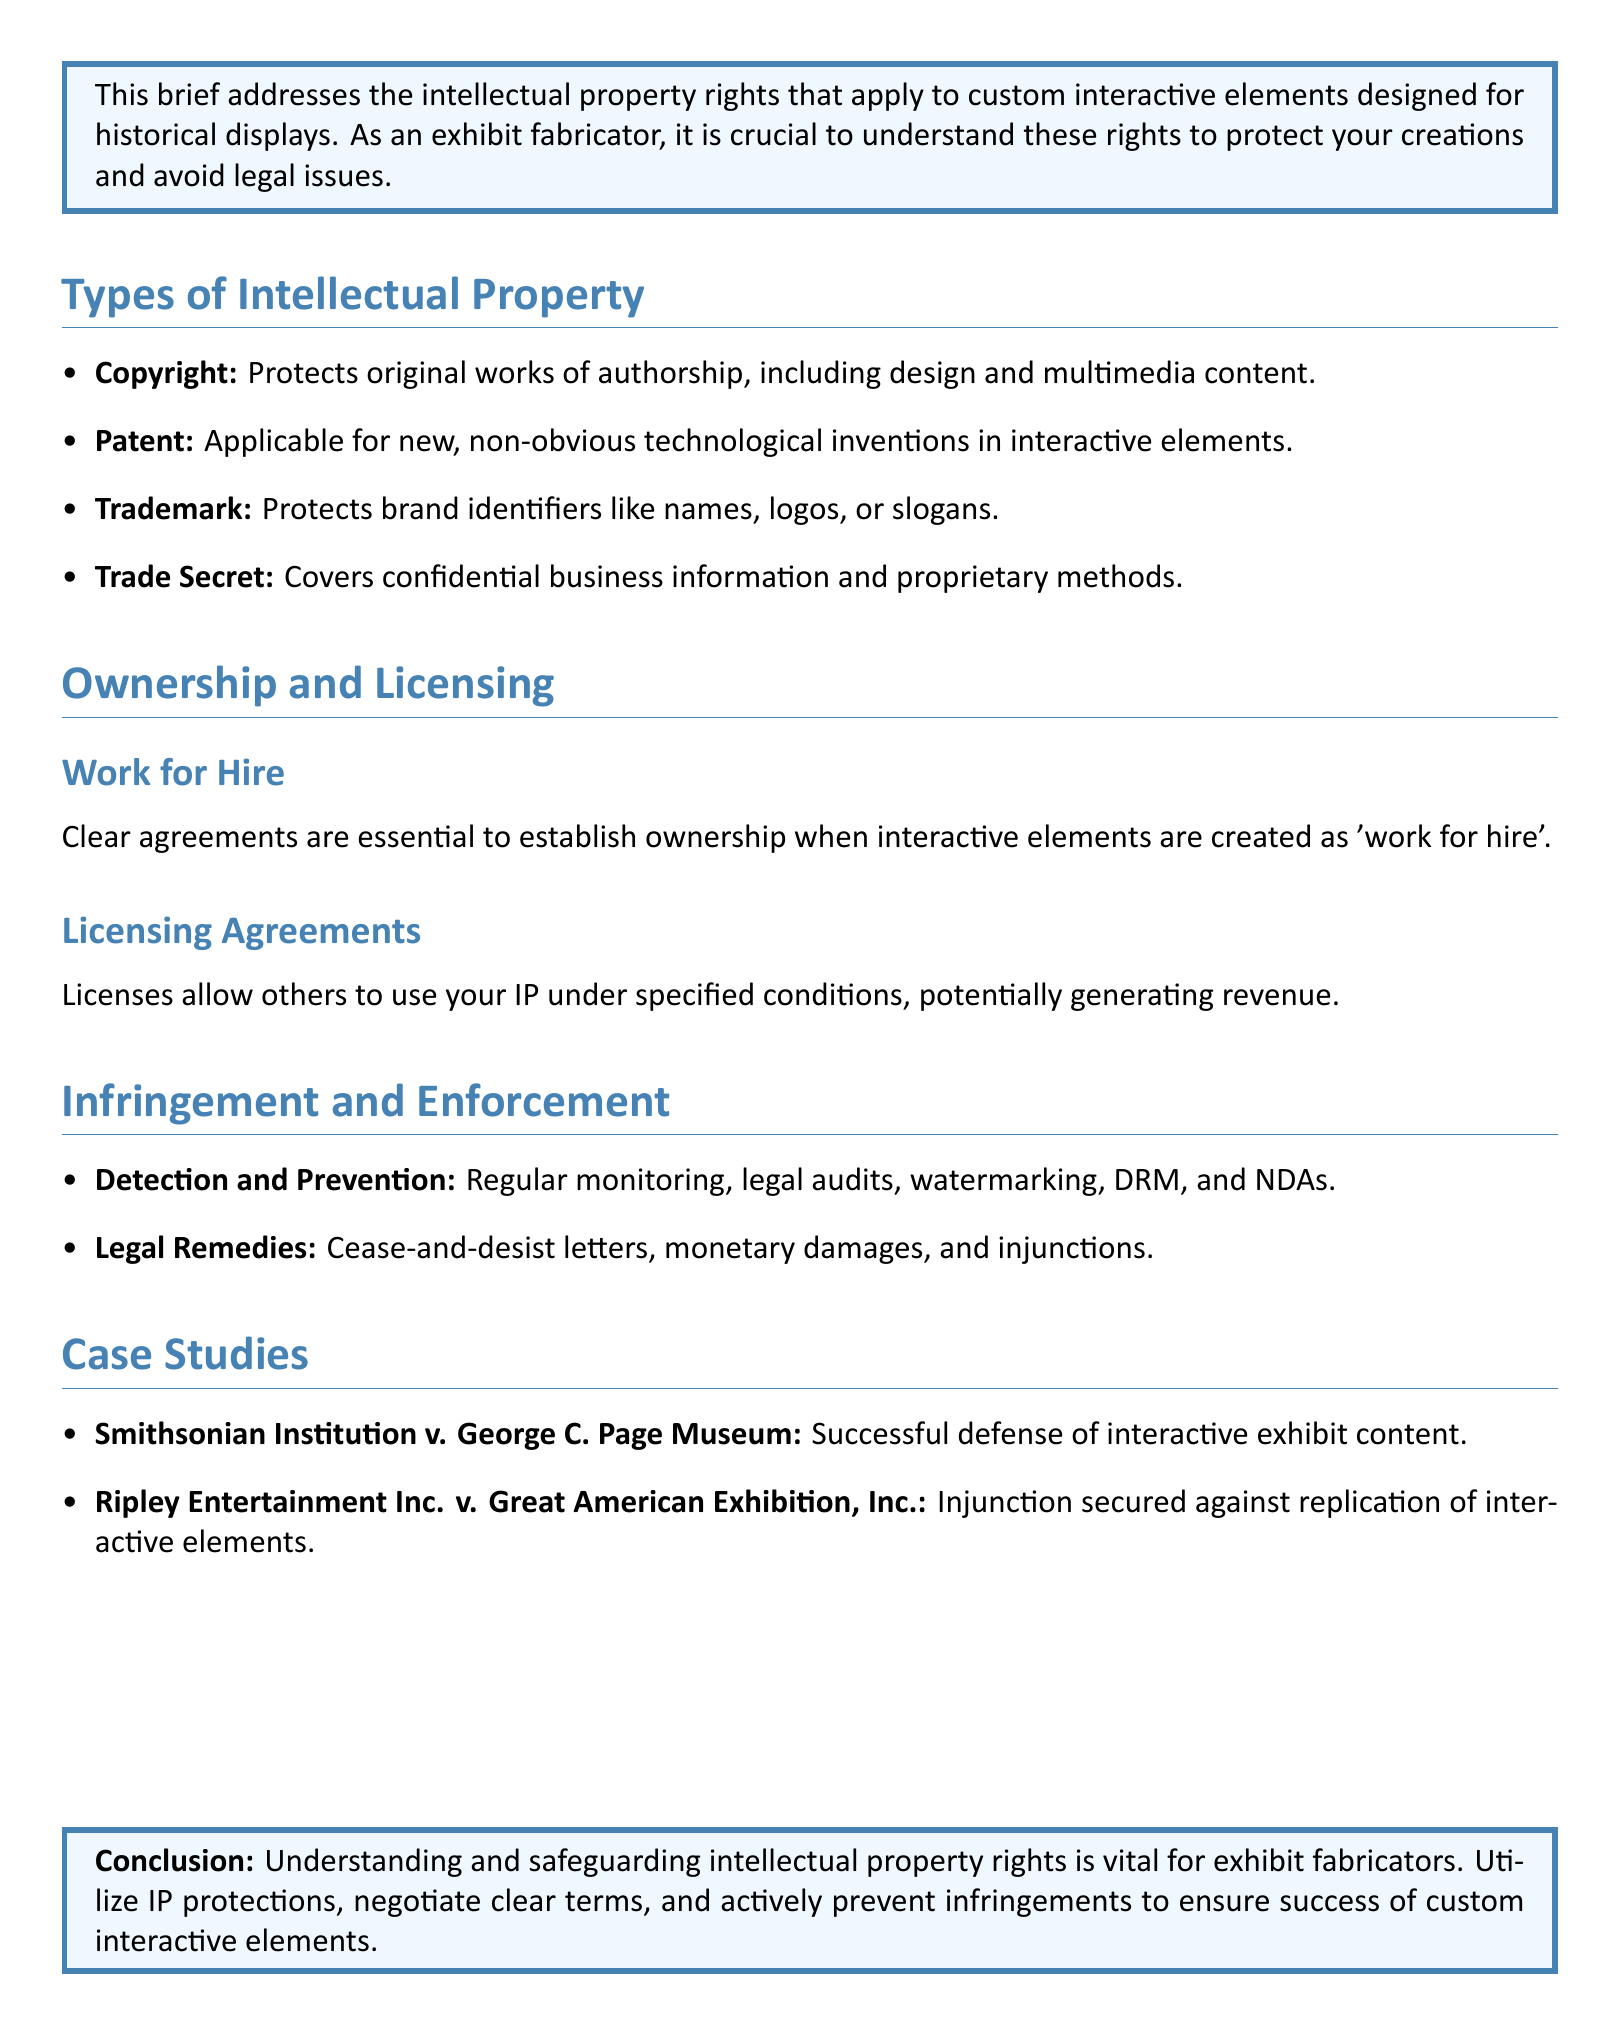What are the four types of intellectual property mentioned? The document lists four types of intellectual property: Copyright, Patent, Trademark, and Trade Secret.
Answer: Copyright, Patent, Trademark, Trade Secret What is the purpose of licensing agreements? Licensing agreements allow others to use your intellectual property under specified conditions, which can generate revenue.
Answer: Generate revenue What case involves the Smithsonian Institution? The document references a case involving the Smithsonian Institution and the George C. Page Museum.
Answer: Smithsonian Institution v. George C. Page Museum What is a potential legal remedy for infringement? The document cites cease-and-desist letters, monetary damages, and injunctions as legal remedies for infringement.
Answer: Cease-and-desist letters What is the conclusion of the legal brief? The conclusion emphasizes understanding and safeguarding intellectual property rights is crucial for exhibit fabricators.
Answer: Understanding and safeguarding intellectual property rights 